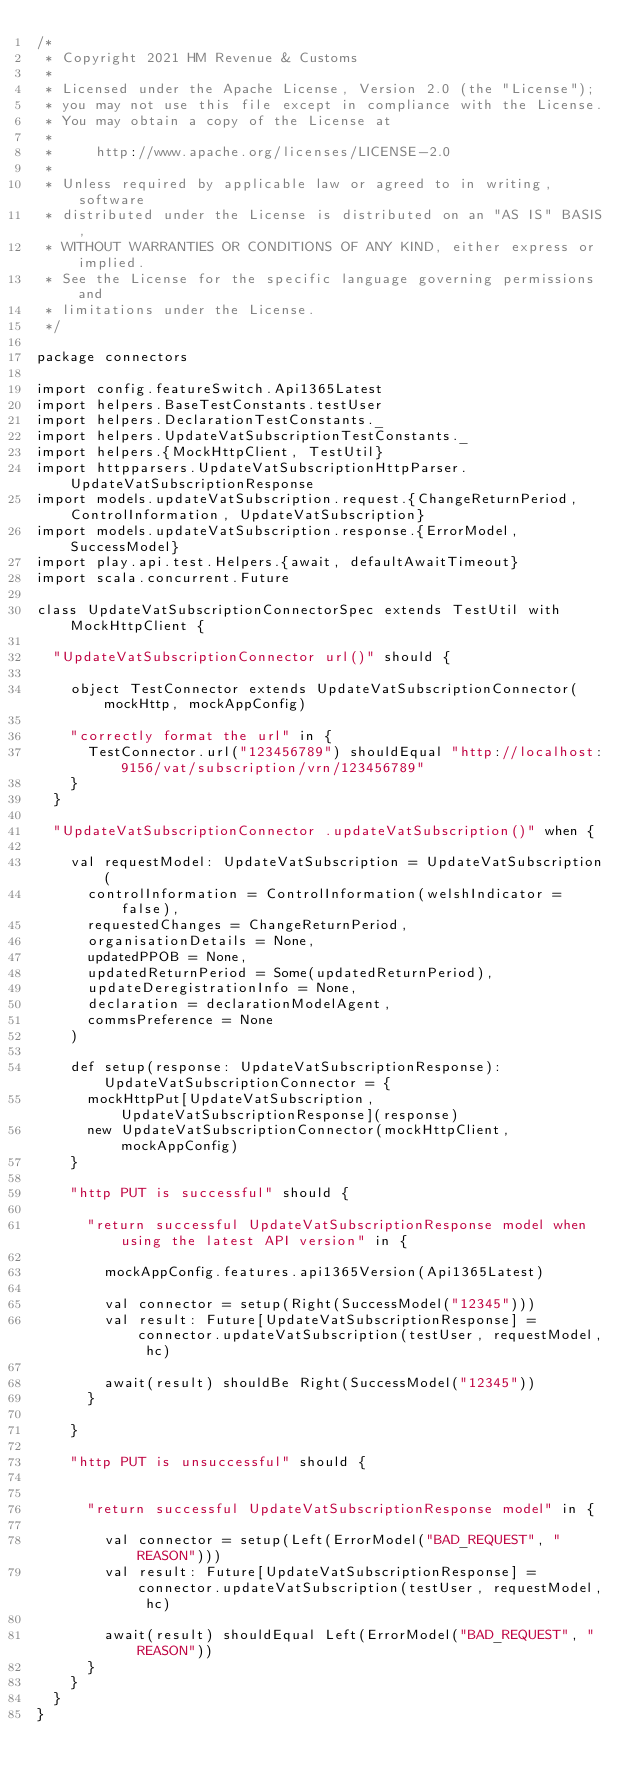Convert code to text. <code><loc_0><loc_0><loc_500><loc_500><_Scala_>/*
 * Copyright 2021 HM Revenue & Customs
 *
 * Licensed under the Apache License, Version 2.0 (the "License");
 * you may not use this file except in compliance with the License.
 * You may obtain a copy of the License at
 *
 *     http://www.apache.org/licenses/LICENSE-2.0
 *
 * Unless required by applicable law or agreed to in writing, software
 * distributed under the License is distributed on an "AS IS" BASIS,
 * WITHOUT WARRANTIES OR CONDITIONS OF ANY KIND, either express or implied.
 * See the License for the specific language governing permissions and
 * limitations under the License.
 */

package connectors

import config.featureSwitch.Api1365Latest
import helpers.BaseTestConstants.testUser
import helpers.DeclarationTestConstants._
import helpers.UpdateVatSubscriptionTestConstants._
import helpers.{MockHttpClient, TestUtil}
import httpparsers.UpdateVatSubscriptionHttpParser.UpdateVatSubscriptionResponse
import models.updateVatSubscription.request.{ChangeReturnPeriod, ControlInformation, UpdateVatSubscription}
import models.updateVatSubscription.response.{ErrorModel, SuccessModel}
import play.api.test.Helpers.{await, defaultAwaitTimeout}
import scala.concurrent.Future

class UpdateVatSubscriptionConnectorSpec extends TestUtil with MockHttpClient {

  "UpdateVatSubscriptionConnector url()" should {

    object TestConnector extends UpdateVatSubscriptionConnector(mockHttp, mockAppConfig)

    "correctly format the url" in {
      TestConnector.url("123456789") shouldEqual "http://localhost:9156/vat/subscription/vrn/123456789"
    }
  }

  "UpdateVatSubscriptionConnector .updateVatSubscription()" when {

    val requestModel: UpdateVatSubscription = UpdateVatSubscription(
      controlInformation = ControlInformation(welshIndicator = false),
      requestedChanges = ChangeReturnPeriod,
      organisationDetails = None,
      updatedPPOB = None,
      updatedReturnPeriod = Some(updatedReturnPeriod),
      updateDeregistrationInfo = None,
      declaration = declarationModelAgent,
      commsPreference = None
    )

    def setup(response: UpdateVatSubscriptionResponse): UpdateVatSubscriptionConnector = {
      mockHttpPut[UpdateVatSubscription, UpdateVatSubscriptionResponse](response)
      new UpdateVatSubscriptionConnector(mockHttpClient, mockAppConfig)
    }

    "http PUT is successful" should {

      "return successful UpdateVatSubscriptionResponse model when using the latest API version" in {

        mockAppConfig.features.api1365Version(Api1365Latest)

        val connector = setup(Right(SuccessModel("12345")))
        val result: Future[UpdateVatSubscriptionResponse] = connector.updateVatSubscription(testUser, requestModel, hc)

        await(result) shouldBe Right(SuccessModel("12345"))
      }

    }

    "http PUT is unsuccessful" should {


      "return successful UpdateVatSubscriptionResponse model" in {

        val connector = setup(Left(ErrorModel("BAD_REQUEST", "REASON")))
        val result: Future[UpdateVatSubscriptionResponse] = connector.updateVatSubscription(testUser, requestModel, hc)

        await(result) shouldEqual Left(ErrorModel("BAD_REQUEST", "REASON"))
      }
    }
  }
}
</code> 